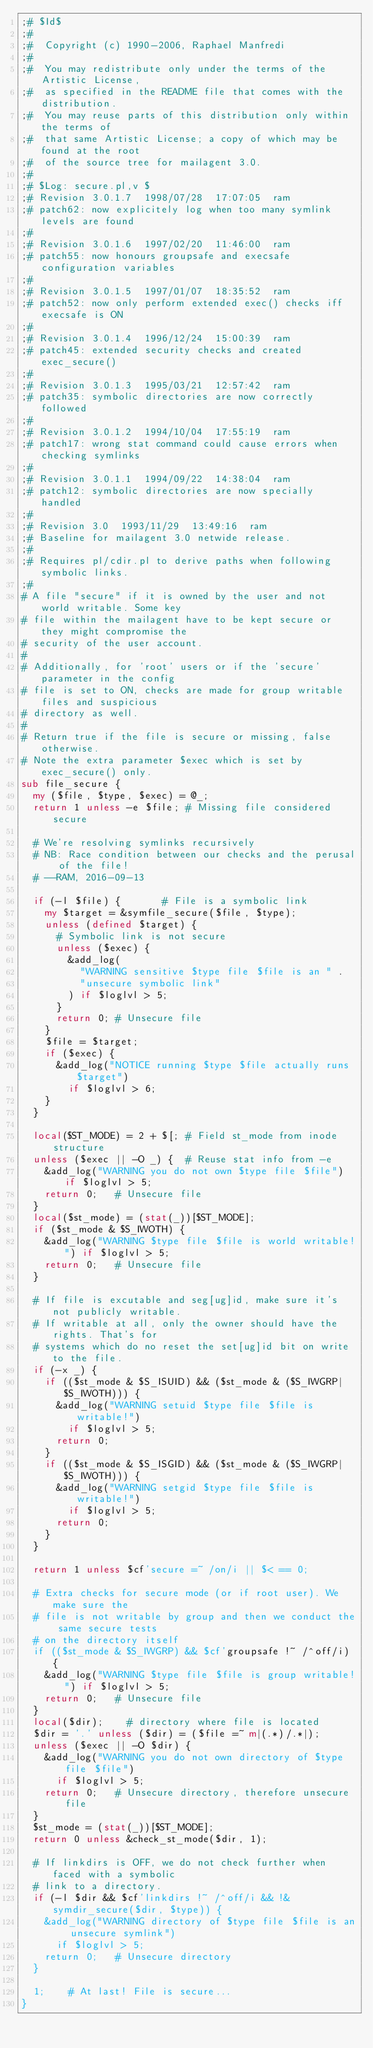Convert code to text. <code><loc_0><loc_0><loc_500><loc_500><_Perl_>;# $Id$
;#
;#  Copyright (c) 1990-2006, Raphael Manfredi
;#  
;#  You may redistribute only under the terms of the Artistic License,
;#  as specified in the README file that comes with the distribution.
;#  You may reuse parts of this distribution only within the terms of
;#  that same Artistic License; a copy of which may be found at the root
;#  of the source tree for mailagent 3.0.
;#
;# $Log: secure.pl,v $
;# Revision 3.0.1.7  1998/07/28  17:07:05  ram
;# patch62: now explicitely log when too many symlink levels are found
;#
;# Revision 3.0.1.6  1997/02/20  11:46:00  ram
;# patch55: now honours groupsafe and execsafe configuration variables
;#
;# Revision 3.0.1.5  1997/01/07  18:35:52  ram
;# patch52: now only perform extended exec() checks iff execsafe is ON
;#
;# Revision 3.0.1.4  1996/12/24  15:00:39  ram
;# patch45: extended security checks and created exec_secure()
;#
;# Revision 3.0.1.3  1995/03/21  12:57:42  ram
;# patch35: symbolic directories are now correctly followed
;#
;# Revision 3.0.1.2  1994/10/04  17:55:19  ram
;# patch17: wrong stat command could cause errors when checking symlinks
;#
;# Revision 3.0.1.1  1994/09/22  14:38:04  ram
;# patch12: symbolic directories are now specially handled
;#
;# Revision 3.0  1993/11/29  13:49:16  ram
;# Baseline for mailagent 3.0 netwide release.
;#
;# Requires pl/cdir.pl to derive paths when following symbolic links.
;# 
# A file "secure" if it is owned by the user and not world writable. Some key
# file within the mailagent have to be kept secure or they might compromise the
# security of the user account.
#
# Additionally, for 'root' users or if the 'secure' parameter in the config
# file is set to ON, checks are made for group writable files and suspicious
# directory as well.
#
# Return true if the file is secure or missing, false otherwise.
# Note the extra parameter $exec which is set by exec_secure() only.
sub file_secure {
	my ($file, $type, $exec) = @_;
	return 1 unless -e $file;	# Missing file considered secure

	# We're resolving symlinks recursively
	# NB: Race condition between our checks and the perusal of the file!
	#	--RAM, 2016-09-13

	if (-l $file) {				# File is a symbolic link
		my $target = &symfile_secure($file, $type);
		unless (defined $target) {
			# Symbolic link is not secure
			unless ($exec) {
				&add_log(
					"WARNING sensitive $type file $file is an " .
					"unsecure symbolic link"
				) if $loglvl > 5;
			}
			return 0;	# Unsecure file
		}
		$file = $target;
		if ($exec) {
			&add_log("NOTICE running $type $file actually runs $target")
				if $loglvl > 6;
		}
	}

	local($ST_MODE) = 2 + $[;	# Field st_mode from inode structure
	unless ($exec || -O _) {	# Reuse stat info from -e
		&add_log("WARNING you do not own $type file $file") if $loglvl > 5;
		return 0;		# Unsecure file
	}
	local($st_mode) = (stat(_))[$ST_MODE];
	if ($st_mode & $S_IWOTH) {
		&add_log("WARNING $type file $file is world writable!") if $loglvl > 5;
		return 0;		# Unsecure file
	}

	# If file is excutable and seg[ug]id, make sure it's not publicly writable.
	# If writable at all, only the owner should have the rights. That's for
	# systems which do no reset the set[ug]id bit on write to the file.
	if (-x _) {
		if (($st_mode & $S_ISUID) && ($st_mode & ($S_IWGRP|$S_IWOTH))) {
			&add_log("WARNING setuid $type file $file is writable!")
				if $loglvl > 5;
			return 0;
		}
		if (($st_mode & $S_ISGID) && ($st_mode & ($S_IWGRP|$S_IWOTH))) {
			&add_log("WARNING setgid $type file $file is writable!")
				if $loglvl > 5;
			return 0;
		}
	}

	return 1 unless $cf'secure =~ /on/i || $< == 0;

	# Extra checks for secure mode (or if root user). We make sure the
	# file is not writable by group and then we conduct the same secure tests
	# on the directory itself
	if (($st_mode & $S_IWGRP) && $cf'groupsafe !~ /^off/i) {
		&add_log("WARNING $type file $file is group writable!") if $loglvl > 5;
		return 0;		# Unsecure file
	}
	local($dir);		# directory where file is located
	$dir = '.' unless ($dir) = ($file =~ m|(.*)/.*|);
	unless ($exec || -O $dir) {
		&add_log("WARNING you do not own directory of $type file $file")
			if $loglvl > 5;
		return 0;		# Unsecure directory, therefore unsecure file
	}
	$st_mode = (stat(_))[$ST_MODE];
	return 0 unless &check_st_mode($dir, 1);

	# If linkdirs is OFF, we do not check further when faced with a symbolic
	# link to a directory.
	if (-l $dir && $cf'linkdirs !~ /^off/i && !&symdir_secure($dir, $type)) {
		&add_log("WARNING directory of $type file $file is an unsecure symlink")
			if $loglvl > 5;
		return 0;		# Unsecure directory
	}

	1;		# At last! File is secure...
}
</code> 